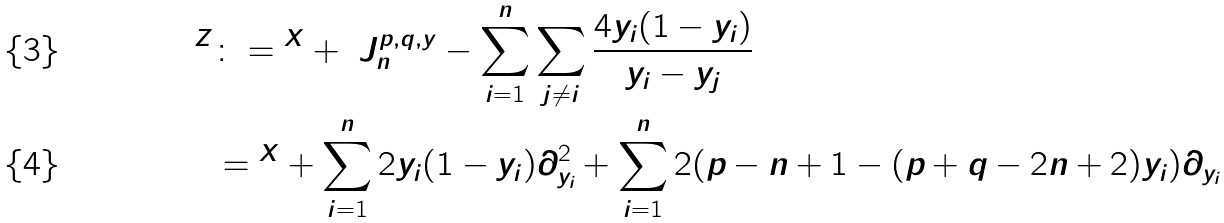Convert formula to latex. <formula><loc_0><loc_0><loc_500><loc_500>\AA ^ { Z } & \colon = \AA ^ { X } + \ J ^ { p , q , y } _ { n } - \sum _ { i = 1 } ^ { n } \sum _ { j \neq i } \frac { 4 y _ { i } ( 1 - y _ { i } ) } { y _ { i } - y _ { j } } \\ & = \AA ^ { X } + \sum _ { i = 1 } ^ { n } 2 y _ { i } ( 1 - y _ { i } ) \partial _ { y _ { i } } ^ { 2 } + \sum _ { i = 1 } ^ { n } 2 ( p - n + 1 - ( p + q - 2 n + 2 ) y _ { i } ) \partial _ { y _ { i } }</formula> 